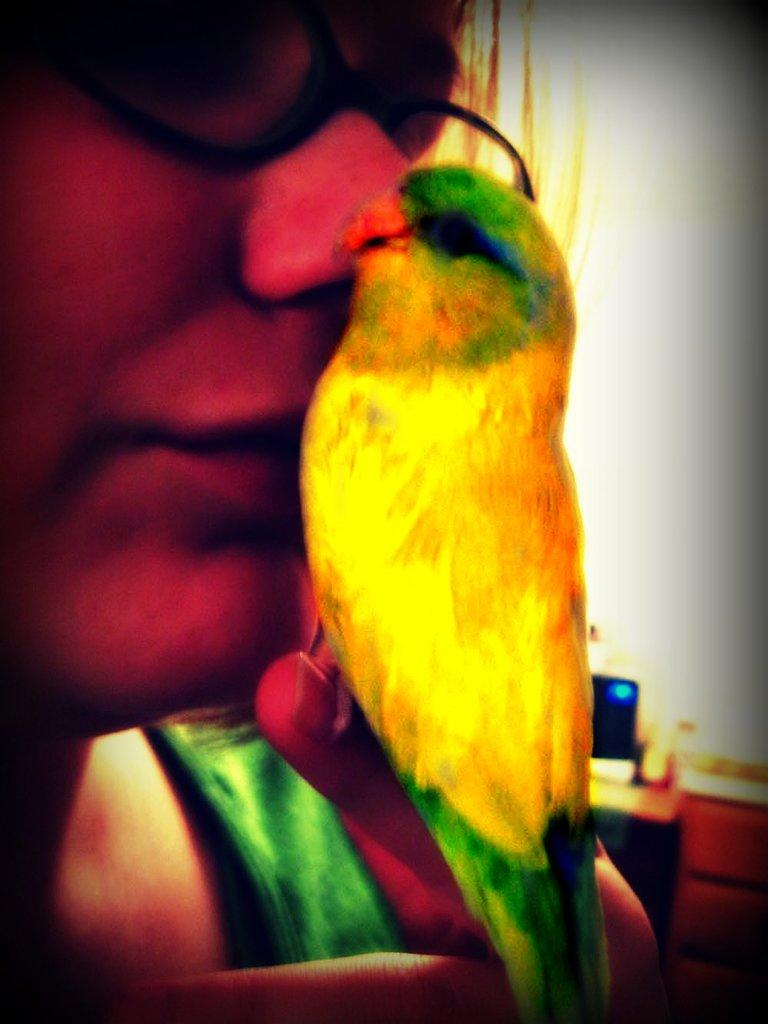Who is the main subject in the image? There is a woman in the image. What is the woman holding in the image? The woman is holding a parrot. Where is the parrot located in relation to the woman? The parrot is on her hand. What can be seen on the woman's face in the image? The woman is wearing spectacles. What colors are visible on the parrot in the image? The parrot is yellow and green in color. Can you hear the parrot's voice in the image? There is no sound in the image, so it is not possible to hear the parrot's voice. 